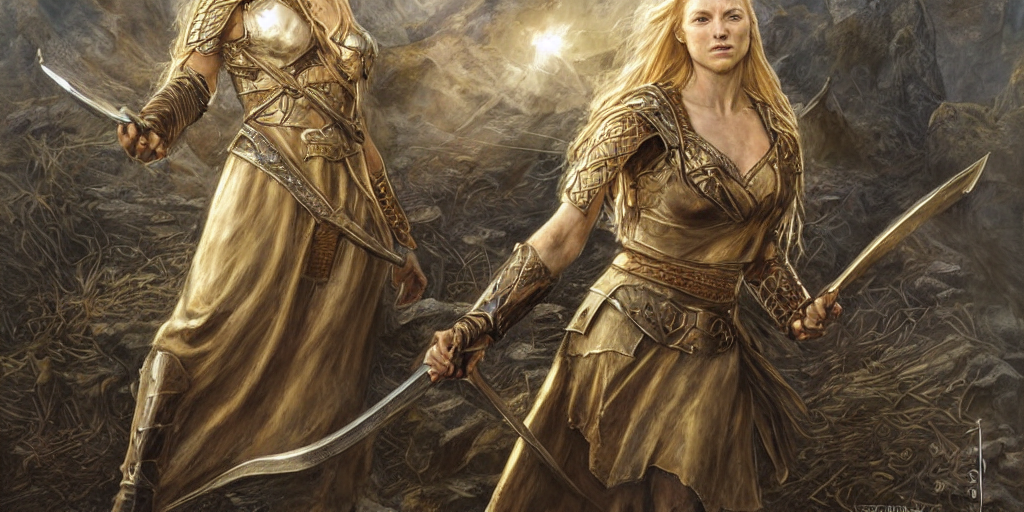What story might this image be illustrating? This image could illustrate a moment from a fantasy epic where the characters, possibly warriors or heroines, are preparing for a significant event such as a battle. Their refined armor and imposing weapons suggest they are of high rank or importance within their narrative world. 